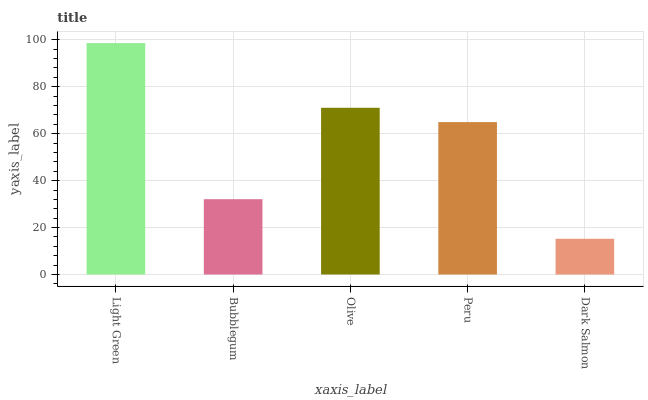Is Bubblegum the minimum?
Answer yes or no. No. Is Bubblegum the maximum?
Answer yes or no. No. Is Light Green greater than Bubblegum?
Answer yes or no. Yes. Is Bubblegum less than Light Green?
Answer yes or no. Yes. Is Bubblegum greater than Light Green?
Answer yes or no. No. Is Light Green less than Bubblegum?
Answer yes or no. No. Is Peru the high median?
Answer yes or no. Yes. Is Peru the low median?
Answer yes or no. Yes. Is Olive the high median?
Answer yes or no. No. Is Bubblegum the low median?
Answer yes or no. No. 